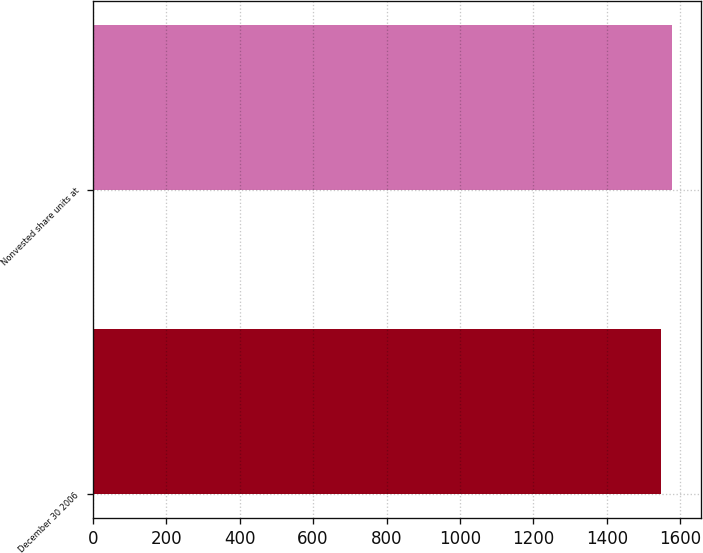<chart> <loc_0><loc_0><loc_500><loc_500><bar_chart><fcel>December 30 2006<fcel>Nonvested share units at<nl><fcel>1546<fcel>1578<nl></chart> 